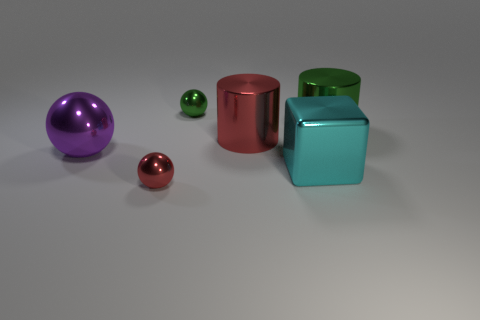Add 4 cyan matte cylinders. How many objects exist? 10 Subtract all blue spheres. Subtract all gray cylinders. How many spheres are left? 3 Subtract all cylinders. How many objects are left? 4 Add 3 red cylinders. How many red cylinders are left? 4 Add 5 large rubber spheres. How many large rubber spheres exist? 5 Subtract 0 gray cubes. How many objects are left? 6 Subtract all shiny cylinders. Subtract all balls. How many objects are left? 1 